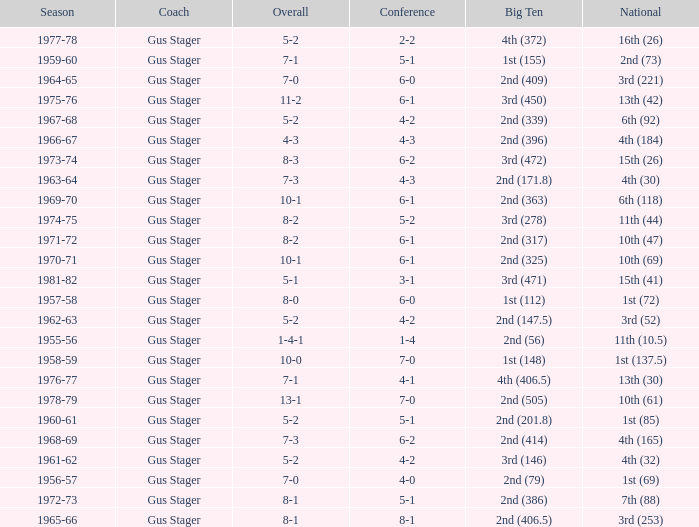What is the Coach with a Big Ten that is 3rd (278)? Gus Stager. 